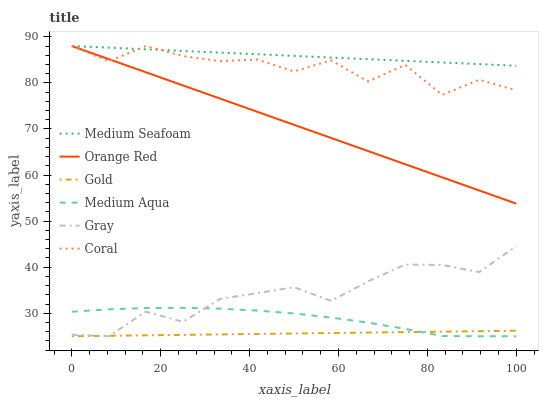Does Gold have the minimum area under the curve?
Answer yes or no. Yes. Does Medium Seafoam have the maximum area under the curve?
Answer yes or no. Yes. Does Coral have the minimum area under the curve?
Answer yes or no. No. Does Coral have the maximum area under the curve?
Answer yes or no. No. Is Gold the smoothest?
Answer yes or no. Yes. Is Coral the roughest?
Answer yes or no. Yes. Is Coral the smoothest?
Answer yes or no. No. Is Gold the roughest?
Answer yes or no. No. Does Gray have the lowest value?
Answer yes or no. Yes. Does Coral have the lowest value?
Answer yes or no. No. Does Medium Seafoam have the highest value?
Answer yes or no. Yes. Does Gold have the highest value?
Answer yes or no. No. Is Medium Aqua less than Coral?
Answer yes or no. Yes. Is Coral greater than Gold?
Answer yes or no. Yes. Does Orange Red intersect Coral?
Answer yes or no. Yes. Is Orange Red less than Coral?
Answer yes or no. No. Is Orange Red greater than Coral?
Answer yes or no. No. Does Medium Aqua intersect Coral?
Answer yes or no. No. 